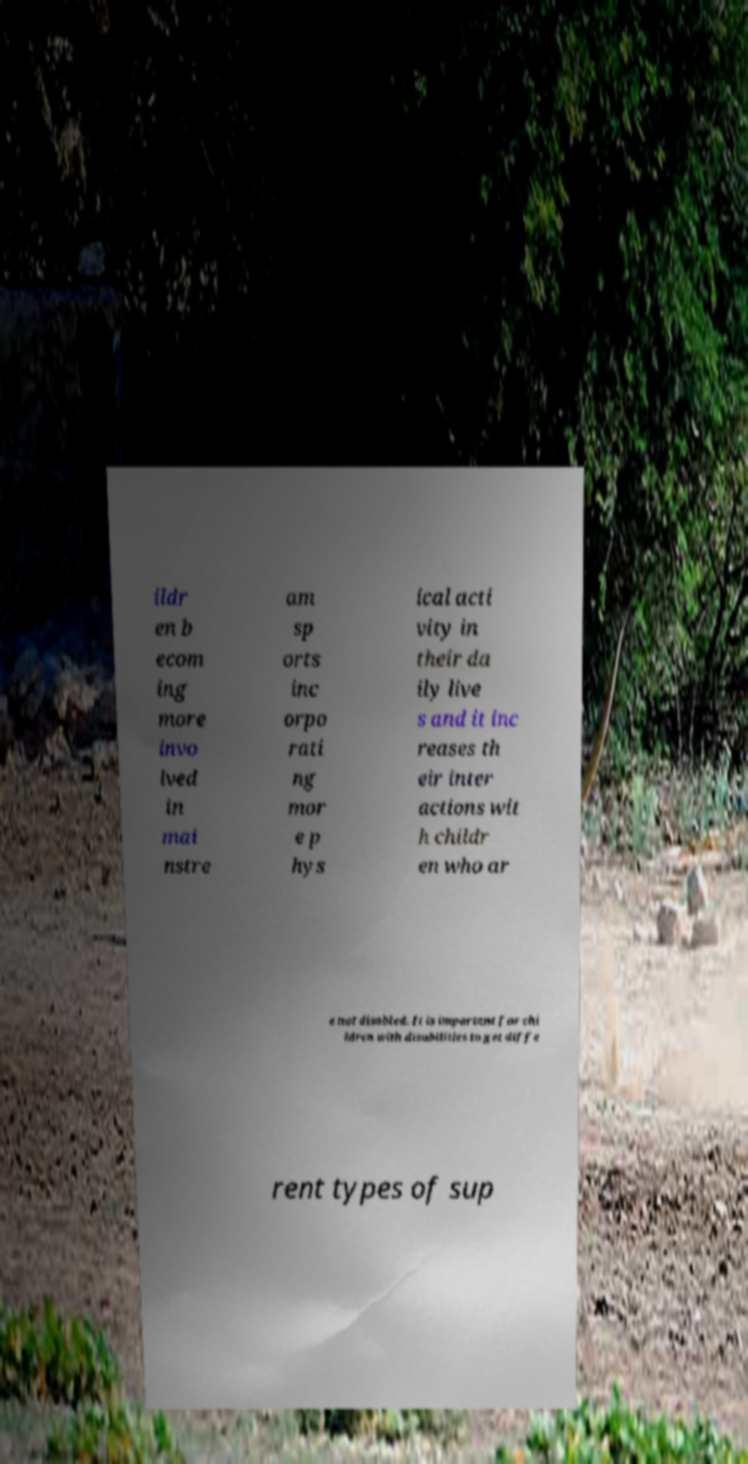Please read and relay the text visible in this image. What does it say? ildr en b ecom ing more invo lved in mai nstre am sp orts inc orpo rati ng mor e p hys ical acti vity in their da ily live s and it inc reases th eir inter actions wit h childr en who ar e not disabled. It is important for chi ldren with disabilities to get diffe rent types of sup 